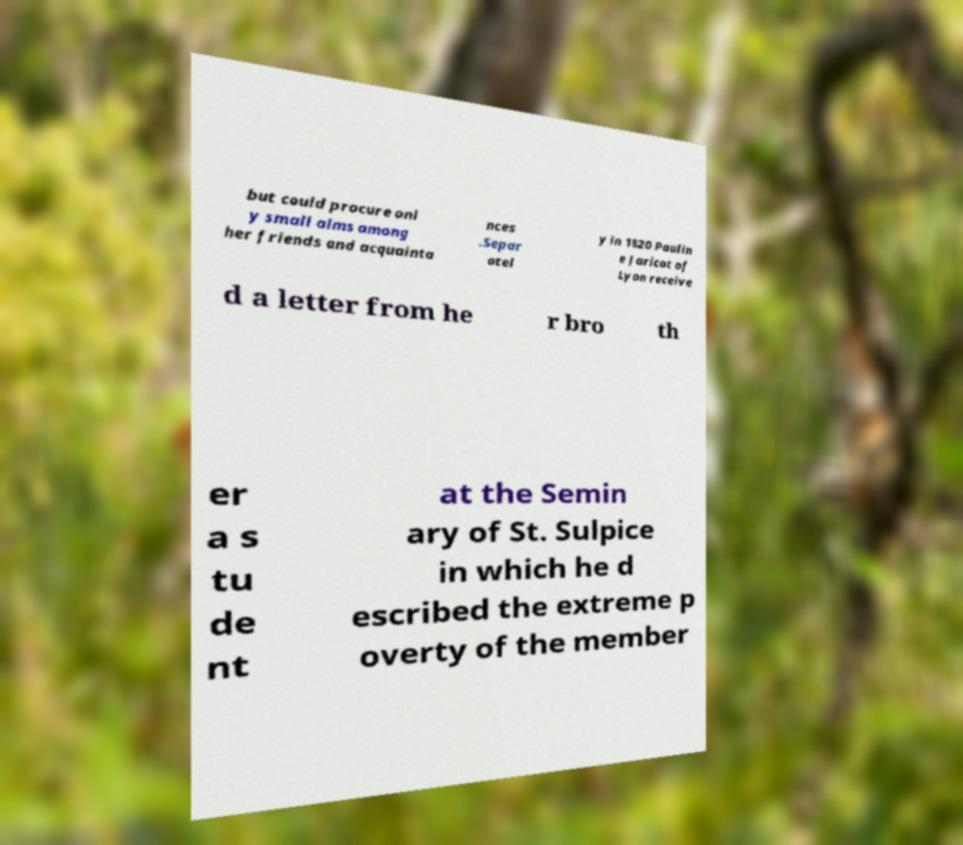For documentation purposes, I need the text within this image transcribed. Could you provide that? but could procure onl y small alms among her friends and acquainta nces .Separ atel y in 1820 Paulin e Jaricot of Lyon receive d a letter from he r bro th er a s tu de nt at the Semin ary of St. Sulpice in which he d escribed the extreme p overty of the member 